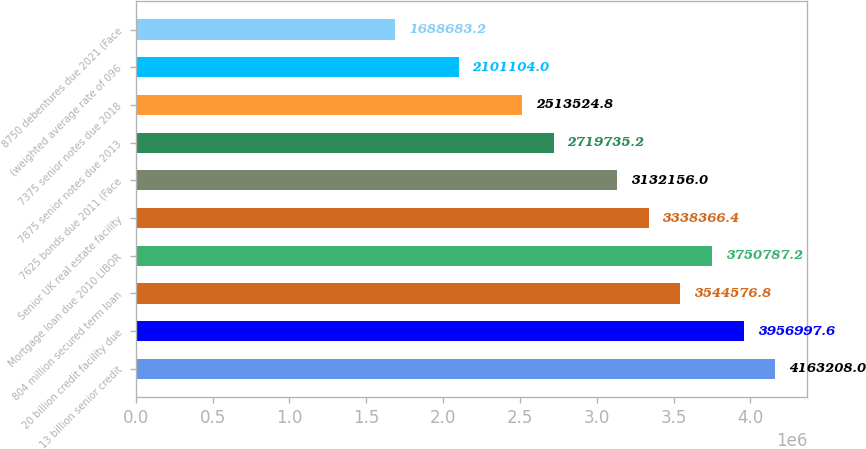Convert chart. <chart><loc_0><loc_0><loc_500><loc_500><bar_chart><fcel>13 billion senior credit<fcel>20 billion credit facility due<fcel>804 million secured term loan<fcel>Mortgage loan due 2010 LIBOR<fcel>Senior UK real estate facility<fcel>7625 bonds due 2011 (Face<fcel>7875 senior notes due 2013<fcel>7375 senior notes due 2018<fcel>(weighted average rate of 096<fcel>8750 debentures due 2021 (Face<nl><fcel>4.16321e+06<fcel>3.957e+06<fcel>3.54458e+06<fcel>3.75079e+06<fcel>3.33837e+06<fcel>3.13216e+06<fcel>2.71974e+06<fcel>2.51352e+06<fcel>2.1011e+06<fcel>1.68868e+06<nl></chart> 